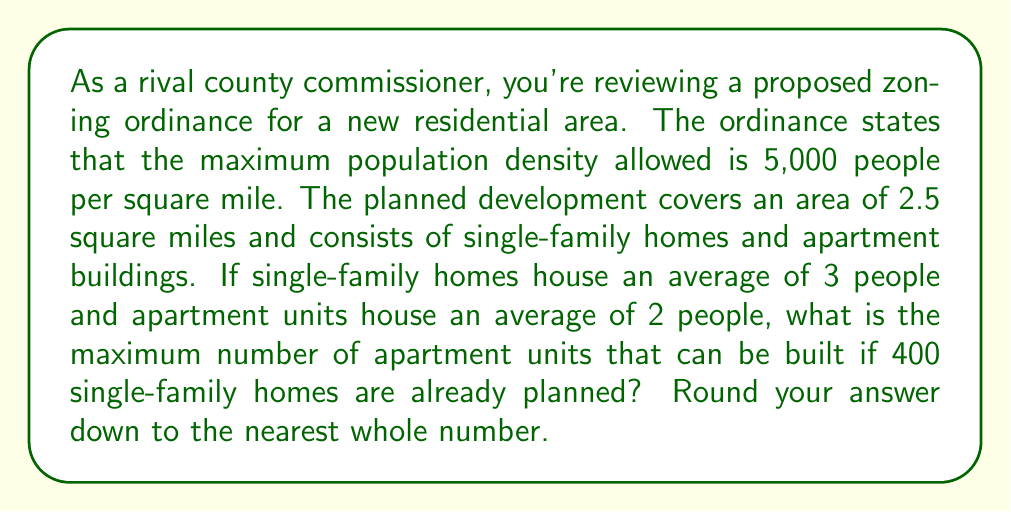Can you answer this question? Let's approach this step-by-step:

1) First, calculate the maximum number of people allowed in the development:
   $$\text{Max population} = \text{Density} \times \text{Area}$$
   $$\text{Max population} = 5,000 \text{ people/sq mile} \times 2.5 \text{ sq miles} = 12,500 \text{ people}$$

2) Calculate the number of people who will live in single-family homes:
   $$\text{People in homes} = \text{Number of homes} \times \text{Average people per home}$$
   $$\text{People in homes} = 400 \times 3 = 1,200 \text{ people}$$

3) Calculate the remaining number of people who can live in apartments:
   $$\text{People in apartments} = \text{Max population} - \text{People in homes}$$
   $$\text{People in apartments} = 12,500 - 1,200 = 11,300 \text{ people}$$

4) Calculate the number of apartment units:
   $$\text{Number of units} = \frac{\text{People in apartments}}{\text{Average people per unit}}$$
   $$\text{Number of units} = \frac{11,300}{2} = 5,650$$

5) Round down to the nearest whole number:
   $$\text{Maximum number of apartment units} = 5,650$$
Answer: 5,650 apartment units 